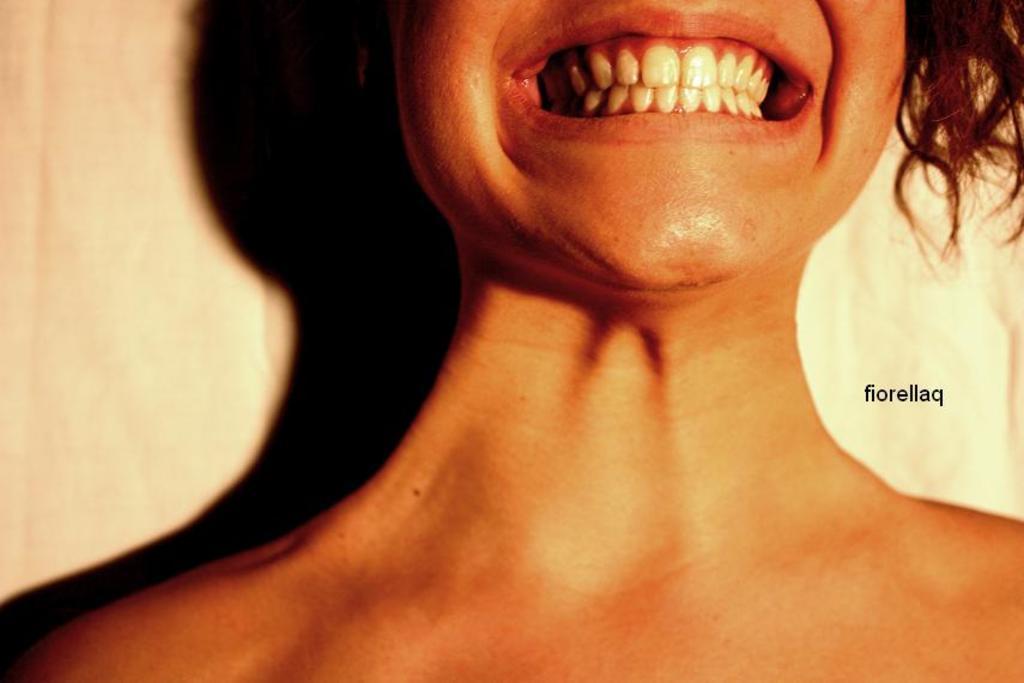In one or two sentences, can you explain what this image depicts? In this picture we can see a person, there is some text on the right side, we can see a plane background. 